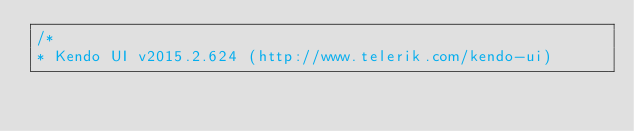Convert code to text. <code><loc_0><loc_0><loc_500><loc_500><_JavaScript_>/*
* Kendo UI v2015.2.624 (http://www.telerik.com/kendo-ui)</code> 